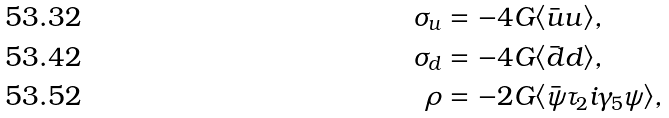<formula> <loc_0><loc_0><loc_500><loc_500>\sigma _ { u } & = - 4 G \langle \bar { u } u \rangle , \\ \sigma _ { d } & = - 4 G \langle \bar { d } d \rangle , \\ \rho & = - 2 G \langle \bar { \psi } \tau _ { 2 } i \gamma _ { 5 } \psi \rangle ,</formula> 